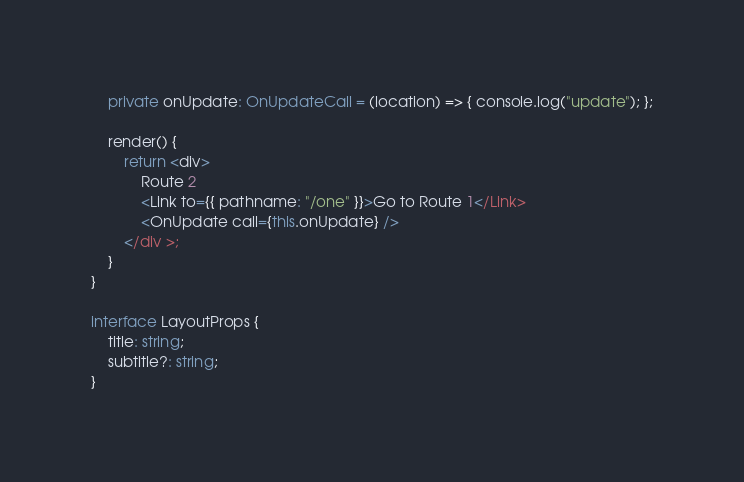<code> <loc_0><loc_0><loc_500><loc_500><_TypeScript_>    private onUpdate: OnUpdateCall = (location) => { console.log("update"); };

    render() {
        return <div>
            Route 2
            <Link to={{ pathname: "/one" }}>Go to Route 1</Link>
            <OnUpdate call={this.onUpdate} />
        </div >;
    }
}

interface LayoutProps {
    title: string;
    subtitle?: string;
}
</code> 